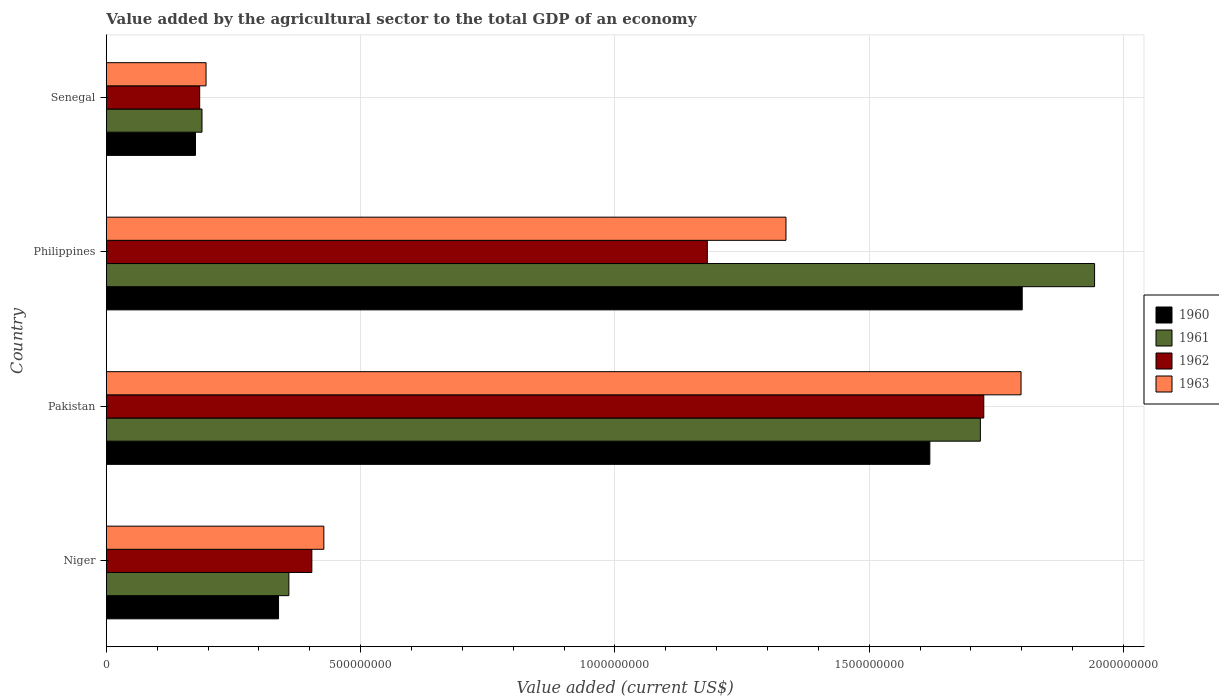How many groups of bars are there?
Offer a very short reply. 4. What is the label of the 4th group of bars from the top?
Keep it short and to the point. Niger. In how many cases, is the number of bars for a given country not equal to the number of legend labels?
Make the answer very short. 0. What is the value added by the agricultural sector to the total GDP in 1962 in Niger?
Offer a very short reply. 4.04e+08. Across all countries, what is the maximum value added by the agricultural sector to the total GDP in 1963?
Your response must be concise. 1.80e+09. Across all countries, what is the minimum value added by the agricultural sector to the total GDP in 1961?
Provide a succinct answer. 1.88e+08. In which country was the value added by the agricultural sector to the total GDP in 1962 maximum?
Your answer should be compact. Pakistan. In which country was the value added by the agricultural sector to the total GDP in 1963 minimum?
Ensure brevity in your answer.  Senegal. What is the total value added by the agricultural sector to the total GDP in 1960 in the graph?
Ensure brevity in your answer.  3.93e+09. What is the difference between the value added by the agricultural sector to the total GDP in 1960 in Niger and that in Pakistan?
Offer a terse response. -1.28e+09. What is the difference between the value added by the agricultural sector to the total GDP in 1960 in Pakistan and the value added by the agricultural sector to the total GDP in 1963 in Philippines?
Your answer should be compact. 2.83e+08. What is the average value added by the agricultural sector to the total GDP in 1960 per country?
Keep it short and to the point. 9.84e+08. What is the difference between the value added by the agricultural sector to the total GDP in 1961 and value added by the agricultural sector to the total GDP in 1962 in Senegal?
Your answer should be compact. 4.54e+06. What is the ratio of the value added by the agricultural sector to the total GDP in 1963 in Pakistan to that in Senegal?
Offer a terse response. 9.17. Is the value added by the agricultural sector to the total GDP in 1960 in Pakistan less than that in Senegal?
Provide a succinct answer. No. What is the difference between the highest and the second highest value added by the agricultural sector to the total GDP in 1961?
Make the answer very short. 2.25e+08. What is the difference between the highest and the lowest value added by the agricultural sector to the total GDP in 1963?
Provide a succinct answer. 1.60e+09. Is it the case that in every country, the sum of the value added by the agricultural sector to the total GDP in 1963 and value added by the agricultural sector to the total GDP in 1962 is greater than the sum of value added by the agricultural sector to the total GDP in 1961 and value added by the agricultural sector to the total GDP in 1960?
Give a very brief answer. No. What does the 2nd bar from the top in Philippines represents?
Your answer should be very brief. 1962. What does the 2nd bar from the bottom in Senegal represents?
Your answer should be compact. 1961. What is the difference between two consecutive major ticks on the X-axis?
Your answer should be very brief. 5.00e+08. Are the values on the major ticks of X-axis written in scientific E-notation?
Keep it short and to the point. No. Does the graph contain grids?
Offer a very short reply. Yes. How are the legend labels stacked?
Provide a short and direct response. Vertical. What is the title of the graph?
Offer a terse response. Value added by the agricultural sector to the total GDP of an economy. What is the label or title of the X-axis?
Your answer should be very brief. Value added (current US$). What is the Value added (current US$) of 1960 in Niger?
Your answer should be compact. 3.39e+08. What is the Value added (current US$) in 1961 in Niger?
Provide a succinct answer. 3.59e+08. What is the Value added (current US$) of 1962 in Niger?
Your response must be concise. 4.04e+08. What is the Value added (current US$) of 1963 in Niger?
Your answer should be very brief. 4.28e+08. What is the Value added (current US$) of 1960 in Pakistan?
Provide a succinct answer. 1.62e+09. What is the Value added (current US$) in 1961 in Pakistan?
Offer a terse response. 1.72e+09. What is the Value added (current US$) in 1962 in Pakistan?
Offer a very short reply. 1.73e+09. What is the Value added (current US$) of 1963 in Pakistan?
Provide a short and direct response. 1.80e+09. What is the Value added (current US$) of 1960 in Philippines?
Your response must be concise. 1.80e+09. What is the Value added (current US$) of 1961 in Philippines?
Provide a succinct answer. 1.94e+09. What is the Value added (current US$) in 1962 in Philippines?
Provide a succinct answer. 1.18e+09. What is the Value added (current US$) in 1963 in Philippines?
Offer a terse response. 1.34e+09. What is the Value added (current US$) in 1960 in Senegal?
Your answer should be compact. 1.75e+08. What is the Value added (current US$) in 1961 in Senegal?
Your response must be concise. 1.88e+08. What is the Value added (current US$) of 1962 in Senegal?
Provide a short and direct response. 1.84e+08. What is the Value added (current US$) of 1963 in Senegal?
Your answer should be very brief. 1.96e+08. Across all countries, what is the maximum Value added (current US$) in 1960?
Provide a short and direct response. 1.80e+09. Across all countries, what is the maximum Value added (current US$) in 1961?
Provide a short and direct response. 1.94e+09. Across all countries, what is the maximum Value added (current US$) in 1962?
Offer a very short reply. 1.73e+09. Across all countries, what is the maximum Value added (current US$) of 1963?
Make the answer very short. 1.80e+09. Across all countries, what is the minimum Value added (current US$) of 1960?
Your answer should be very brief. 1.75e+08. Across all countries, what is the minimum Value added (current US$) of 1961?
Make the answer very short. 1.88e+08. Across all countries, what is the minimum Value added (current US$) of 1962?
Your answer should be very brief. 1.84e+08. Across all countries, what is the minimum Value added (current US$) of 1963?
Provide a succinct answer. 1.96e+08. What is the total Value added (current US$) of 1960 in the graph?
Provide a succinct answer. 3.93e+09. What is the total Value added (current US$) in 1961 in the graph?
Provide a succinct answer. 4.21e+09. What is the total Value added (current US$) in 1962 in the graph?
Offer a very short reply. 3.49e+09. What is the total Value added (current US$) of 1963 in the graph?
Your answer should be compact. 3.76e+09. What is the difference between the Value added (current US$) in 1960 in Niger and that in Pakistan?
Offer a very short reply. -1.28e+09. What is the difference between the Value added (current US$) of 1961 in Niger and that in Pakistan?
Your answer should be very brief. -1.36e+09. What is the difference between the Value added (current US$) of 1962 in Niger and that in Pakistan?
Provide a succinct answer. -1.32e+09. What is the difference between the Value added (current US$) of 1963 in Niger and that in Pakistan?
Offer a terse response. -1.37e+09. What is the difference between the Value added (current US$) in 1960 in Niger and that in Philippines?
Your answer should be very brief. -1.46e+09. What is the difference between the Value added (current US$) of 1961 in Niger and that in Philippines?
Provide a short and direct response. -1.58e+09. What is the difference between the Value added (current US$) of 1962 in Niger and that in Philippines?
Offer a very short reply. -7.78e+08. What is the difference between the Value added (current US$) of 1963 in Niger and that in Philippines?
Your response must be concise. -9.09e+08. What is the difference between the Value added (current US$) in 1960 in Niger and that in Senegal?
Offer a terse response. 1.63e+08. What is the difference between the Value added (current US$) in 1961 in Niger and that in Senegal?
Your answer should be compact. 1.71e+08. What is the difference between the Value added (current US$) in 1962 in Niger and that in Senegal?
Your answer should be compact. 2.21e+08. What is the difference between the Value added (current US$) in 1963 in Niger and that in Senegal?
Your answer should be compact. 2.32e+08. What is the difference between the Value added (current US$) of 1960 in Pakistan and that in Philippines?
Your answer should be very brief. -1.82e+08. What is the difference between the Value added (current US$) of 1961 in Pakistan and that in Philippines?
Provide a short and direct response. -2.25e+08. What is the difference between the Value added (current US$) in 1962 in Pakistan and that in Philippines?
Make the answer very short. 5.44e+08. What is the difference between the Value added (current US$) in 1963 in Pakistan and that in Philippines?
Ensure brevity in your answer.  4.62e+08. What is the difference between the Value added (current US$) of 1960 in Pakistan and that in Senegal?
Provide a succinct answer. 1.44e+09. What is the difference between the Value added (current US$) in 1961 in Pakistan and that in Senegal?
Provide a short and direct response. 1.53e+09. What is the difference between the Value added (current US$) in 1962 in Pakistan and that in Senegal?
Give a very brief answer. 1.54e+09. What is the difference between the Value added (current US$) of 1963 in Pakistan and that in Senegal?
Offer a terse response. 1.60e+09. What is the difference between the Value added (current US$) of 1960 in Philippines and that in Senegal?
Keep it short and to the point. 1.63e+09. What is the difference between the Value added (current US$) of 1961 in Philippines and that in Senegal?
Ensure brevity in your answer.  1.76e+09. What is the difference between the Value added (current US$) in 1962 in Philippines and that in Senegal?
Give a very brief answer. 9.98e+08. What is the difference between the Value added (current US$) of 1963 in Philippines and that in Senegal?
Provide a short and direct response. 1.14e+09. What is the difference between the Value added (current US$) of 1960 in Niger and the Value added (current US$) of 1961 in Pakistan?
Provide a succinct answer. -1.38e+09. What is the difference between the Value added (current US$) in 1960 in Niger and the Value added (current US$) in 1962 in Pakistan?
Offer a terse response. -1.39e+09. What is the difference between the Value added (current US$) in 1960 in Niger and the Value added (current US$) in 1963 in Pakistan?
Keep it short and to the point. -1.46e+09. What is the difference between the Value added (current US$) in 1961 in Niger and the Value added (current US$) in 1962 in Pakistan?
Provide a short and direct response. -1.37e+09. What is the difference between the Value added (current US$) of 1961 in Niger and the Value added (current US$) of 1963 in Pakistan?
Your answer should be compact. -1.44e+09. What is the difference between the Value added (current US$) in 1962 in Niger and the Value added (current US$) in 1963 in Pakistan?
Provide a short and direct response. -1.39e+09. What is the difference between the Value added (current US$) in 1960 in Niger and the Value added (current US$) in 1961 in Philippines?
Provide a short and direct response. -1.60e+09. What is the difference between the Value added (current US$) in 1960 in Niger and the Value added (current US$) in 1962 in Philippines?
Ensure brevity in your answer.  -8.43e+08. What is the difference between the Value added (current US$) in 1960 in Niger and the Value added (current US$) in 1963 in Philippines?
Keep it short and to the point. -9.98e+08. What is the difference between the Value added (current US$) in 1961 in Niger and the Value added (current US$) in 1962 in Philippines?
Give a very brief answer. -8.23e+08. What is the difference between the Value added (current US$) in 1961 in Niger and the Value added (current US$) in 1963 in Philippines?
Give a very brief answer. -9.77e+08. What is the difference between the Value added (current US$) in 1962 in Niger and the Value added (current US$) in 1963 in Philippines?
Offer a very short reply. -9.32e+08. What is the difference between the Value added (current US$) of 1960 in Niger and the Value added (current US$) of 1961 in Senegal?
Keep it short and to the point. 1.50e+08. What is the difference between the Value added (current US$) of 1960 in Niger and the Value added (current US$) of 1962 in Senegal?
Make the answer very short. 1.55e+08. What is the difference between the Value added (current US$) of 1960 in Niger and the Value added (current US$) of 1963 in Senegal?
Provide a succinct answer. 1.43e+08. What is the difference between the Value added (current US$) in 1961 in Niger and the Value added (current US$) in 1962 in Senegal?
Your answer should be very brief. 1.75e+08. What is the difference between the Value added (current US$) in 1961 in Niger and the Value added (current US$) in 1963 in Senegal?
Your response must be concise. 1.63e+08. What is the difference between the Value added (current US$) in 1962 in Niger and the Value added (current US$) in 1963 in Senegal?
Provide a succinct answer. 2.08e+08. What is the difference between the Value added (current US$) in 1960 in Pakistan and the Value added (current US$) in 1961 in Philippines?
Your answer should be very brief. -3.24e+08. What is the difference between the Value added (current US$) in 1960 in Pakistan and the Value added (current US$) in 1962 in Philippines?
Provide a succinct answer. 4.38e+08. What is the difference between the Value added (current US$) of 1960 in Pakistan and the Value added (current US$) of 1963 in Philippines?
Ensure brevity in your answer.  2.83e+08. What is the difference between the Value added (current US$) in 1961 in Pakistan and the Value added (current US$) in 1962 in Philippines?
Offer a terse response. 5.37e+08. What is the difference between the Value added (current US$) in 1961 in Pakistan and the Value added (current US$) in 1963 in Philippines?
Your answer should be very brief. 3.82e+08. What is the difference between the Value added (current US$) in 1962 in Pakistan and the Value added (current US$) in 1963 in Philippines?
Provide a succinct answer. 3.89e+08. What is the difference between the Value added (current US$) of 1960 in Pakistan and the Value added (current US$) of 1961 in Senegal?
Offer a very short reply. 1.43e+09. What is the difference between the Value added (current US$) of 1960 in Pakistan and the Value added (current US$) of 1962 in Senegal?
Make the answer very short. 1.44e+09. What is the difference between the Value added (current US$) of 1960 in Pakistan and the Value added (current US$) of 1963 in Senegal?
Your answer should be compact. 1.42e+09. What is the difference between the Value added (current US$) in 1961 in Pakistan and the Value added (current US$) in 1962 in Senegal?
Your response must be concise. 1.54e+09. What is the difference between the Value added (current US$) of 1961 in Pakistan and the Value added (current US$) of 1963 in Senegal?
Keep it short and to the point. 1.52e+09. What is the difference between the Value added (current US$) in 1962 in Pakistan and the Value added (current US$) in 1963 in Senegal?
Your answer should be compact. 1.53e+09. What is the difference between the Value added (current US$) of 1960 in Philippines and the Value added (current US$) of 1961 in Senegal?
Your answer should be compact. 1.61e+09. What is the difference between the Value added (current US$) of 1960 in Philippines and the Value added (current US$) of 1962 in Senegal?
Offer a very short reply. 1.62e+09. What is the difference between the Value added (current US$) of 1960 in Philippines and the Value added (current US$) of 1963 in Senegal?
Keep it short and to the point. 1.60e+09. What is the difference between the Value added (current US$) of 1961 in Philippines and the Value added (current US$) of 1962 in Senegal?
Ensure brevity in your answer.  1.76e+09. What is the difference between the Value added (current US$) of 1961 in Philippines and the Value added (current US$) of 1963 in Senegal?
Provide a short and direct response. 1.75e+09. What is the difference between the Value added (current US$) of 1962 in Philippines and the Value added (current US$) of 1963 in Senegal?
Your answer should be compact. 9.86e+08. What is the average Value added (current US$) of 1960 per country?
Give a very brief answer. 9.84e+08. What is the average Value added (current US$) in 1961 per country?
Keep it short and to the point. 1.05e+09. What is the average Value added (current US$) in 1962 per country?
Your response must be concise. 8.74e+08. What is the average Value added (current US$) in 1963 per country?
Ensure brevity in your answer.  9.40e+08. What is the difference between the Value added (current US$) of 1960 and Value added (current US$) of 1961 in Niger?
Make the answer very short. -2.03e+07. What is the difference between the Value added (current US$) in 1960 and Value added (current US$) in 1962 in Niger?
Your answer should be very brief. -6.55e+07. What is the difference between the Value added (current US$) in 1960 and Value added (current US$) in 1963 in Niger?
Offer a terse response. -8.91e+07. What is the difference between the Value added (current US$) of 1961 and Value added (current US$) of 1962 in Niger?
Give a very brief answer. -4.52e+07. What is the difference between the Value added (current US$) of 1961 and Value added (current US$) of 1963 in Niger?
Your answer should be very brief. -6.88e+07. What is the difference between the Value added (current US$) of 1962 and Value added (current US$) of 1963 in Niger?
Your answer should be compact. -2.36e+07. What is the difference between the Value added (current US$) in 1960 and Value added (current US$) in 1961 in Pakistan?
Your response must be concise. -9.93e+07. What is the difference between the Value added (current US$) of 1960 and Value added (current US$) of 1962 in Pakistan?
Offer a very short reply. -1.06e+08. What is the difference between the Value added (current US$) of 1960 and Value added (current US$) of 1963 in Pakistan?
Offer a very short reply. -1.79e+08. What is the difference between the Value added (current US$) in 1961 and Value added (current US$) in 1962 in Pakistan?
Provide a short and direct response. -6.72e+06. What is the difference between the Value added (current US$) of 1961 and Value added (current US$) of 1963 in Pakistan?
Ensure brevity in your answer.  -8.00e+07. What is the difference between the Value added (current US$) in 1962 and Value added (current US$) in 1963 in Pakistan?
Your answer should be very brief. -7.33e+07. What is the difference between the Value added (current US$) of 1960 and Value added (current US$) of 1961 in Philippines?
Give a very brief answer. -1.42e+08. What is the difference between the Value added (current US$) in 1960 and Value added (current US$) in 1962 in Philippines?
Make the answer very short. 6.19e+08. What is the difference between the Value added (current US$) of 1960 and Value added (current US$) of 1963 in Philippines?
Provide a succinct answer. 4.64e+08. What is the difference between the Value added (current US$) in 1961 and Value added (current US$) in 1962 in Philippines?
Provide a succinct answer. 7.61e+08. What is the difference between the Value added (current US$) of 1961 and Value added (current US$) of 1963 in Philippines?
Ensure brevity in your answer.  6.07e+08. What is the difference between the Value added (current US$) of 1962 and Value added (current US$) of 1963 in Philippines?
Your response must be concise. -1.55e+08. What is the difference between the Value added (current US$) in 1960 and Value added (current US$) in 1961 in Senegal?
Offer a very short reply. -1.28e+07. What is the difference between the Value added (current US$) of 1960 and Value added (current US$) of 1962 in Senegal?
Your answer should be compact. -8.24e+06. What is the difference between the Value added (current US$) of 1960 and Value added (current US$) of 1963 in Senegal?
Keep it short and to the point. -2.07e+07. What is the difference between the Value added (current US$) in 1961 and Value added (current US$) in 1962 in Senegal?
Offer a very short reply. 4.54e+06. What is the difference between the Value added (current US$) of 1961 and Value added (current US$) of 1963 in Senegal?
Ensure brevity in your answer.  -7.96e+06. What is the difference between the Value added (current US$) in 1962 and Value added (current US$) in 1963 in Senegal?
Your answer should be very brief. -1.25e+07. What is the ratio of the Value added (current US$) of 1960 in Niger to that in Pakistan?
Your response must be concise. 0.21. What is the ratio of the Value added (current US$) in 1961 in Niger to that in Pakistan?
Your response must be concise. 0.21. What is the ratio of the Value added (current US$) in 1962 in Niger to that in Pakistan?
Keep it short and to the point. 0.23. What is the ratio of the Value added (current US$) of 1963 in Niger to that in Pakistan?
Provide a short and direct response. 0.24. What is the ratio of the Value added (current US$) of 1960 in Niger to that in Philippines?
Make the answer very short. 0.19. What is the ratio of the Value added (current US$) of 1961 in Niger to that in Philippines?
Provide a succinct answer. 0.18. What is the ratio of the Value added (current US$) of 1962 in Niger to that in Philippines?
Ensure brevity in your answer.  0.34. What is the ratio of the Value added (current US$) in 1963 in Niger to that in Philippines?
Provide a succinct answer. 0.32. What is the ratio of the Value added (current US$) in 1960 in Niger to that in Senegal?
Your answer should be very brief. 1.93. What is the ratio of the Value added (current US$) of 1961 in Niger to that in Senegal?
Your answer should be very brief. 1.91. What is the ratio of the Value added (current US$) in 1962 in Niger to that in Senegal?
Offer a terse response. 2.2. What is the ratio of the Value added (current US$) in 1963 in Niger to that in Senegal?
Your response must be concise. 2.18. What is the ratio of the Value added (current US$) in 1960 in Pakistan to that in Philippines?
Keep it short and to the point. 0.9. What is the ratio of the Value added (current US$) in 1961 in Pakistan to that in Philippines?
Give a very brief answer. 0.88. What is the ratio of the Value added (current US$) in 1962 in Pakistan to that in Philippines?
Provide a succinct answer. 1.46. What is the ratio of the Value added (current US$) in 1963 in Pakistan to that in Philippines?
Offer a very short reply. 1.35. What is the ratio of the Value added (current US$) in 1960 in Pakistan to that in Senegal?
Make the answer very short. 9.24. What is the ratio of the Value added (current US$) of 1961 in Pakistan to that in Senegal?
Provide a short and direct response. 9.14. What is the ratio of the Value added (current US$) in 1962 in Pakistan to that in Senegal?
Provide a short and direct response. 9.4. What is the ratio of the Value added (current US$) in 1963 in Pakistan to that in Senegal?
Offer a very short reply. 9.17. What is the ratio of the Value added (current US$) in 1960 in Philippines to that in Senegal?
Your answer should be very brief. 10.27. What is the ratio of the Value added (current US$) in 1961 in Philippines to that in Senegal?
Make the answer very short. 10.33. What is the ratio of the Value added (current US$) of 1962 in Philippines to that in Senegal?
Offer a very short reply. 6.44. What is the ratio of the Value added (current US$) in 1963 in Philippines to that in Senegal?
Ensure brevity in your answer.  6.82. What is the difference between the highest and the second highest Value added (current US$) in 1960?
Make the answer very short. 1.82e+08. What is the difference between the highest and the second highest Value added (current US$) of 1961?
Offer a very short reply. 2.25e+08. What is the difference between the highest and the second highest Value added (current US$) of 1962?
Ensure brevity in your answer.  5.44e+08. What is the difference between the highest and the second highest Value added (current US$) in 1963?
Your answer should be compact. 4.62e+08. What is the difference between the highest and the lowest Value added (current US$) of 1960?
Keep it short and to the point. 1.63e+09. What is the difference between the highest and the lowest Value added (current US$) of 1961?
Provide a short and direct response. 1.76e+09. What is the difference between the highest and the lowest Value added (current US$) of 1962?
Your answer should be compact. 1.54e+09. What is the difference between the highest and the lowest Value added (current US$) in 1963?
Offer a terse response. 1.60e+09. 